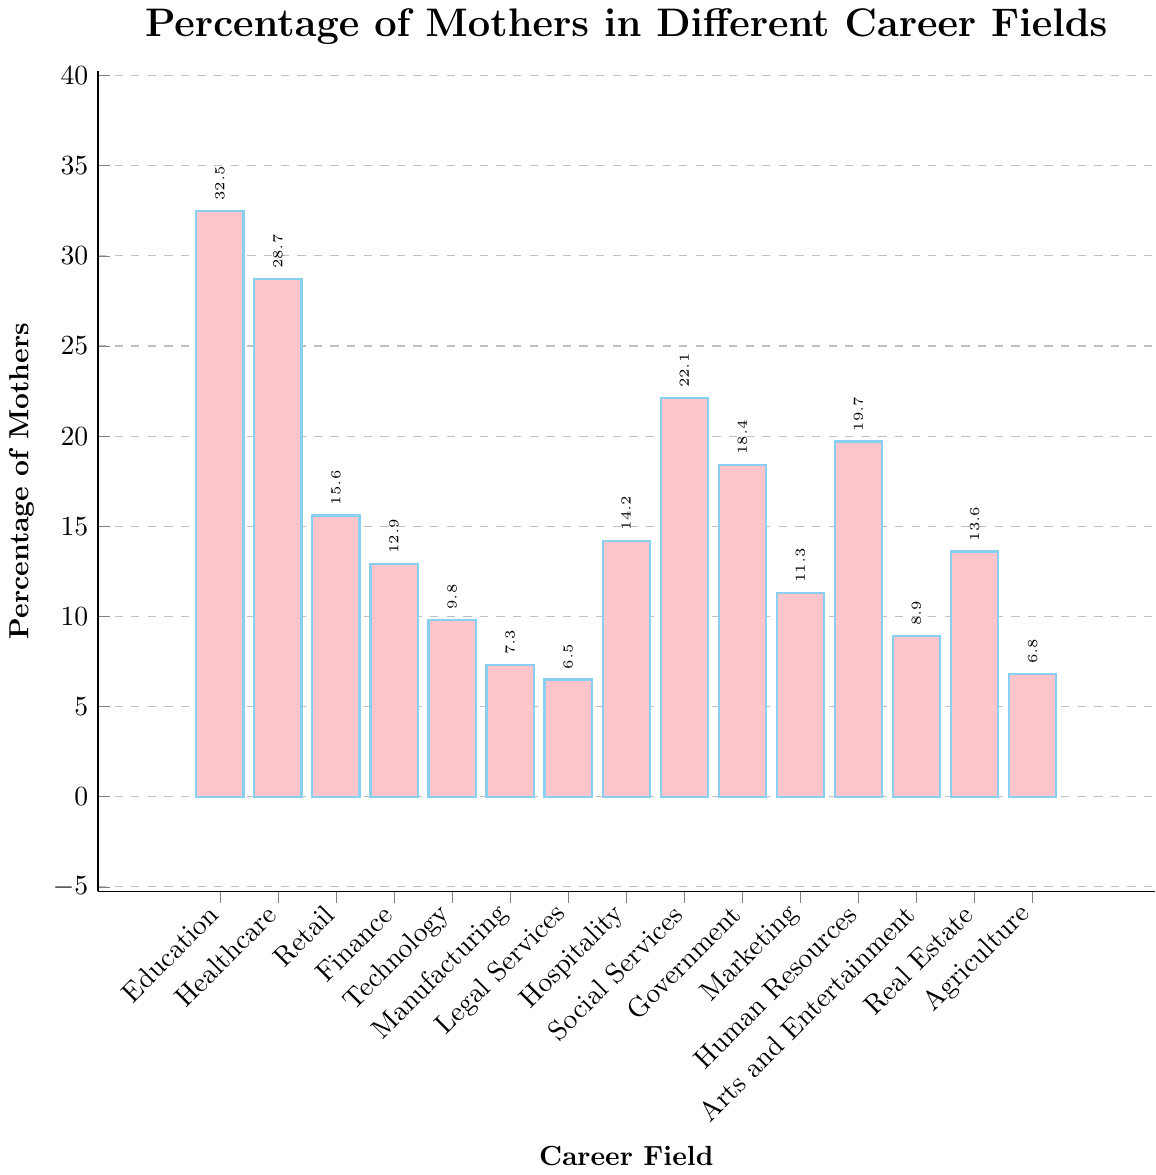Which career field has the highest percentage of mothers? The bar representing the percentage of mothers in "Education" is the tallest in the chart. All other bars are shorter than the bar for "Education."
Answer: Education Compare the percentage of mothers in Healthcare and Technology. Which field has more mothers? The bar for Healthcare is taller than the bar for Technology. This means the percentage of mothers in Healthcare is greater than that in Technology.
Answer: Healthcare What is the percentage difference between the career field with the highest and lowest percentage of mothers? The highest percentage is in Education (32.5%), and the lowest is in Legal Services (6.5%). The difference is calculated as 32.5% - 6.5% = 26%.
Answer: 26% Which career fields have a percentage of mothers greater than 20%? From the chart, the fields with percentages greater than 20% are Education (32.5%), Healthcare (28.7%), Social Services (22.1%), and Human Resources (19.7% is a bit close but not greater than 20%).
Answer: Education, Healthcare, Social Services What is the average percentage of mothers across all the career fields? Sum of the percentages: 32.5 + 28.7 + 15.6 + 12.9 + 9.8 + 7.3 + 6.5 + 14.2 + 22.1 + 18.4 + 11.3 + 19.7 + 8.9 + 13.6 + 6.8 = 228.3. Number of career fields: 15. Average = 228.3 / 15 = 15.22%.
Answer: 15.22% How does the percentage of mothers in Real Estate compare to that in Retail? The bar for Retail shows 15.6%, and the bar for Real Estate shows 13.6%. Retail has a higher percentage of mothers than Real Estate.
Answer: Retail Which career field has nearly half the percentage of mothers as in Education? Education has 32.5%. Half of that is 16.25%. Retail (15.6%), Finance (12.9%), Hospitality (14.2%), Marketing (11.3%), and Real Estate (13.6%) have percentages close to half of 32.5%.
Answer: Retail Identify the fields with percentage differences of less than 1% from one another. Manufacturing (7.3%) and Agriculture (6.8%) have a difference of 0.5%.
Answer: Manufacturing, Agriculture Is the percentage of mothers in Legal Services higher or lower than in Agriculture? The bar for Legal Services shows 6.5%, and the bar for Agriculture shows 6.8%. The percentage in Legal Services is lower than in Agriculture.
Answer: Lower 